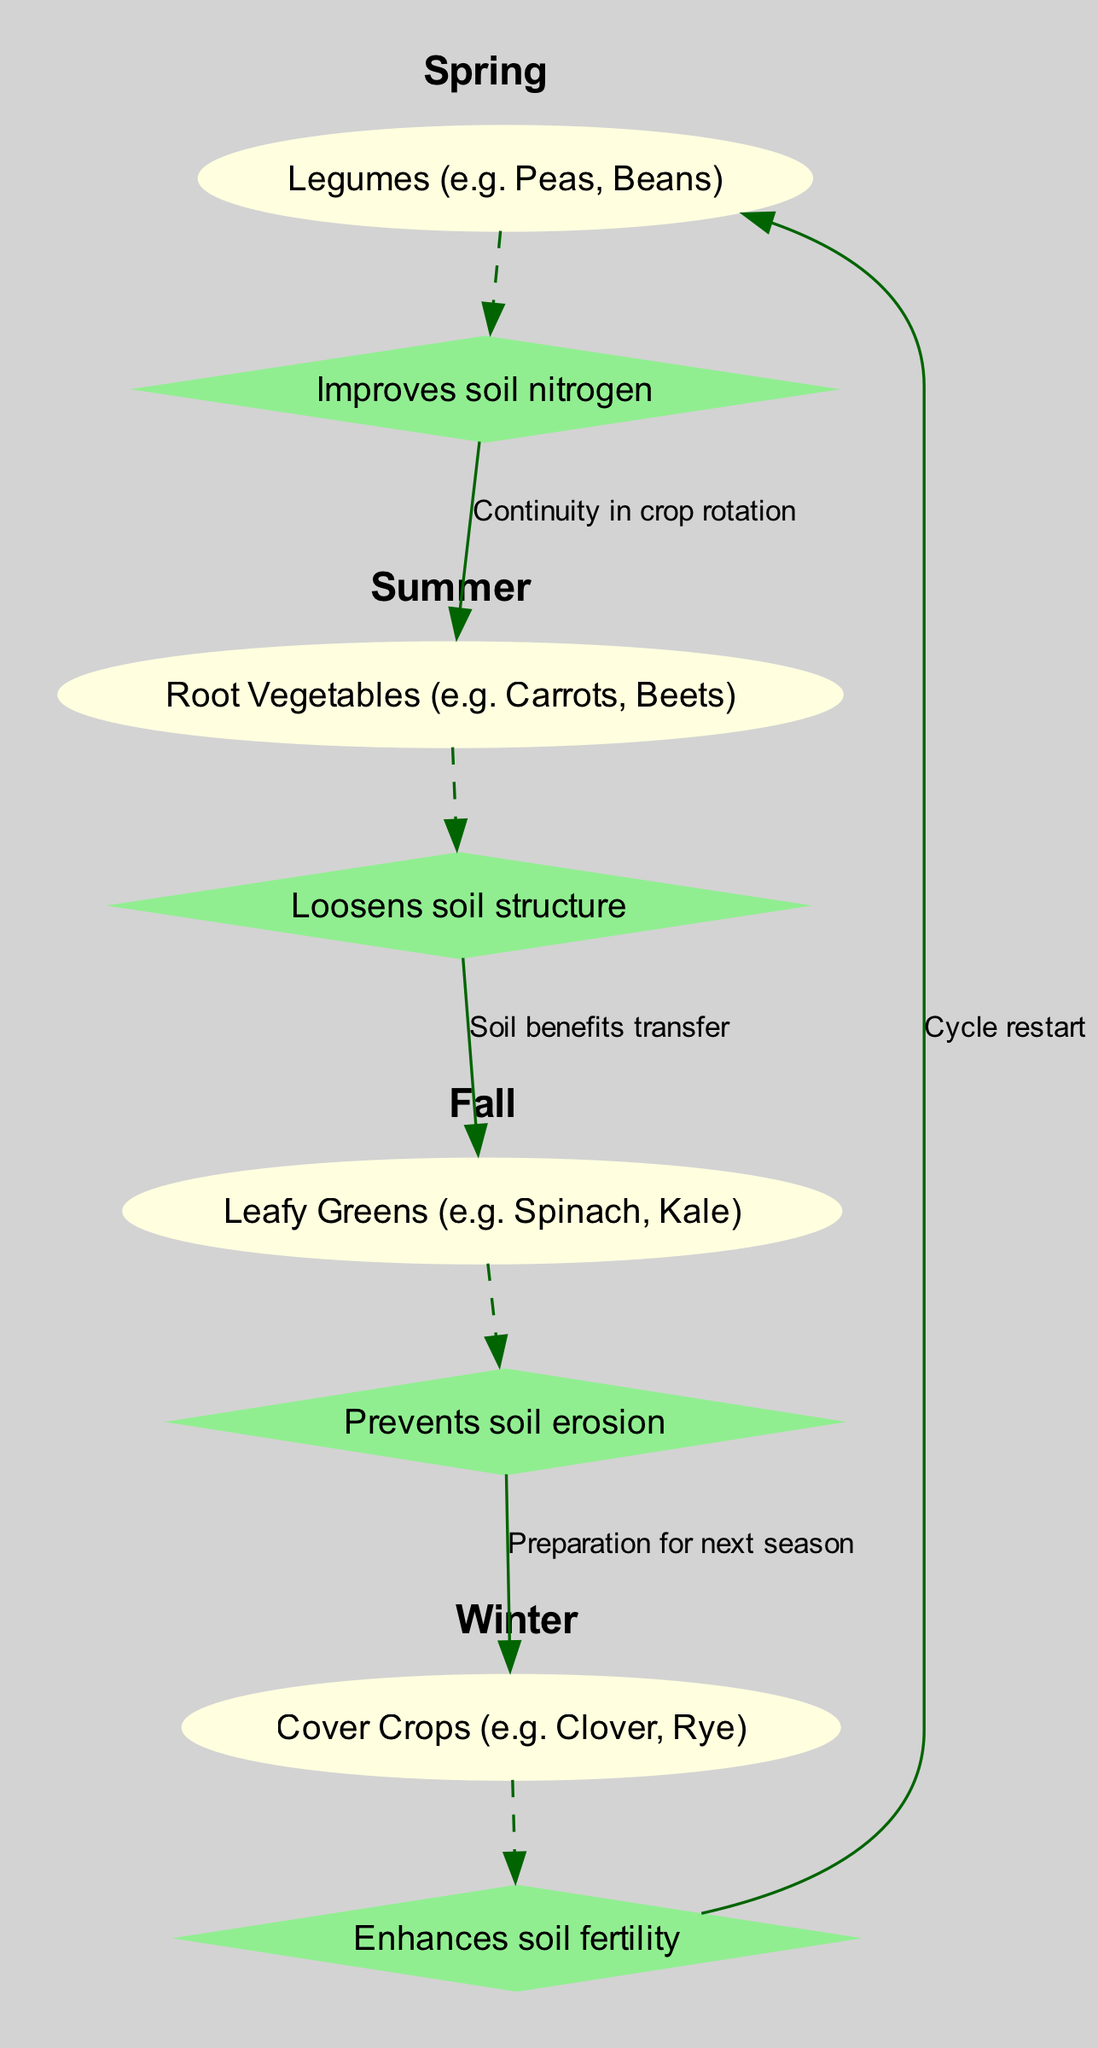What crops are grown in Spring? The diagram indicates that the crops grown in Spring are legumes, which include peas and beans.
Answer: Legumes (e.g. Peas, Beans) What benefit does planting legumes provide? The diagram shows that the benefit of planting legumes in Spring is that they improve soil nitrogen.
Answer: Improves soil nitrogen What type of vegetables are rotated in Summer? According to the diagram, the type of vegetables grown in Summer are root vegetables, such as carrots and beets.
Answer: Root Vegetables (e.g. Carrots, Beets) How many total seasons are shown in the diagram? The diagram lists four seasons: Spring, Summer, Fall, and Winter, making the total count four.
Answer: 4 What is the benefit of planting leafy greens in Fall? The diagram specifies that the benefit of planting leafy greens in Fall is to prevent soil erosion.
Answer: Prevents soil erosion What links Summer to Fall in the crop rotation schedule? The diagram indicates that the link between Summer and Fall is characterized by soil benefits transfer, establishing a continuity of benefits for the crops planted.
Answer: Soil benefits transfer What is the purpose of cover crops planted in Winter? The diagram states that planting cover crops in Winter enhances soil fertility, which is crucial for preparing the soil for the next planting season.
Answer: Enhances soil fertility Which season starts the cycle again after Winter? In examining the diagram, it is clear that Spring is the season that restarts the entire crop rotation cycle after Winter ends.
Answer: Spring What type of relationship does Spring have with Summer? The diagram highlights that the relationship between Spring and Summer is continuity in crop rotation, which indicates that practices from Spring carry over into Summer.
Answer: Continuity in crop rotation 